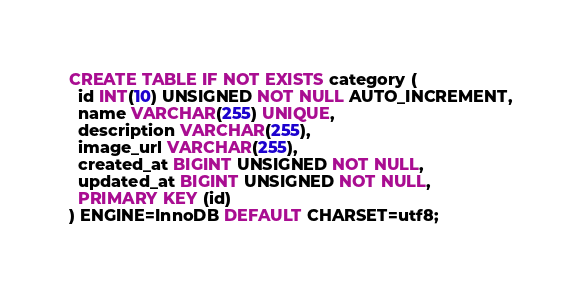<code> <loc_0><loc_0><loc_500><loc_500><_SQL_>CREATE TABLE IF NOT EXISTS category (
  id INT(10) UNSIGNED NOT NULL AUTO_INCREMENT,
  name VARCHAR(255) UNIQUE,
  description VARCHAR(255),
  image_url VARCHAR(255),
  created_at BIGINT UNSIGNED NOT NULL,
  updated_at BIGINT UNSIGNED NOT NULL,
  PRIMARY KEY (id)
) ENGINE=InnoDB DEFAULT CHARSET=utf8;
</code> 